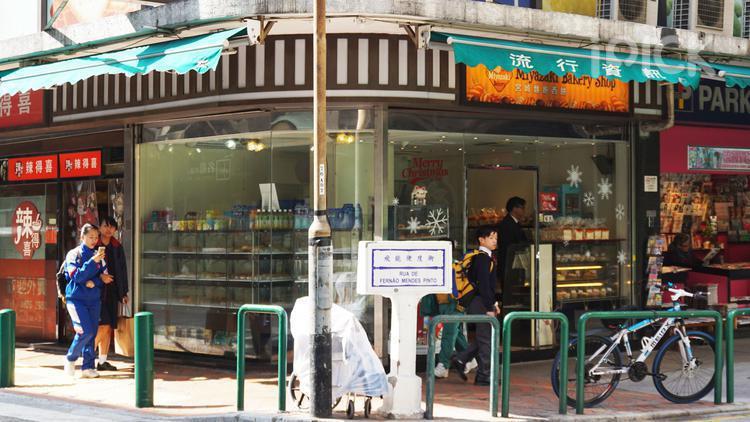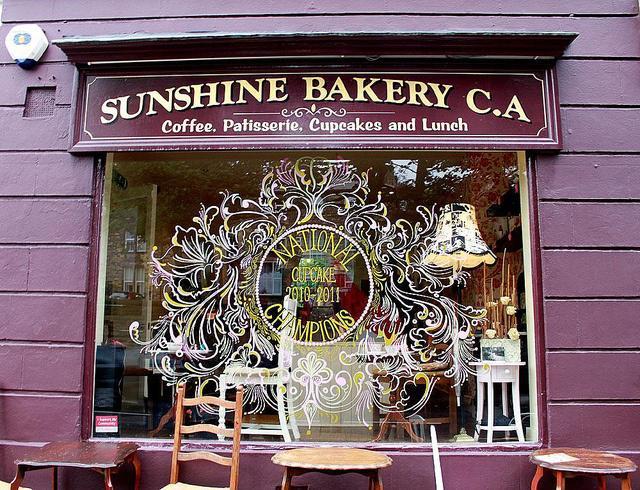The first image is the image on the left, the second image is the image on the right. For the images shown, is this caption "In at least one image there is a shelve of bake goods inside a bakery." true? Answer yes or no. No. The first image is the image on the left, the second image is the image on the right. Examine the images to the left and right. Is the description "One of the shops has tables and chairs out front." accurate? Answer yes or no. Yes. 